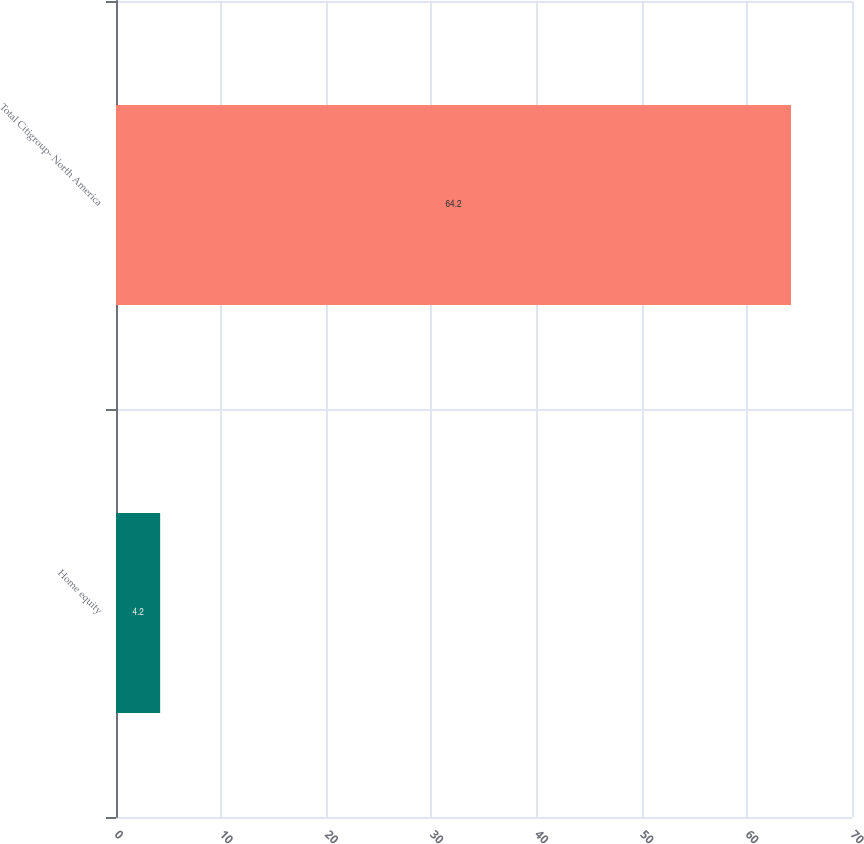Convert chart to OTSL. <chart><loc_0><loc_0><loc_500><loc_500><bar_chart><fcel>Home equity<fcel>Total Citigroup- North America<nl><fcel>4.2<fcel>64.2<nl></chart> 